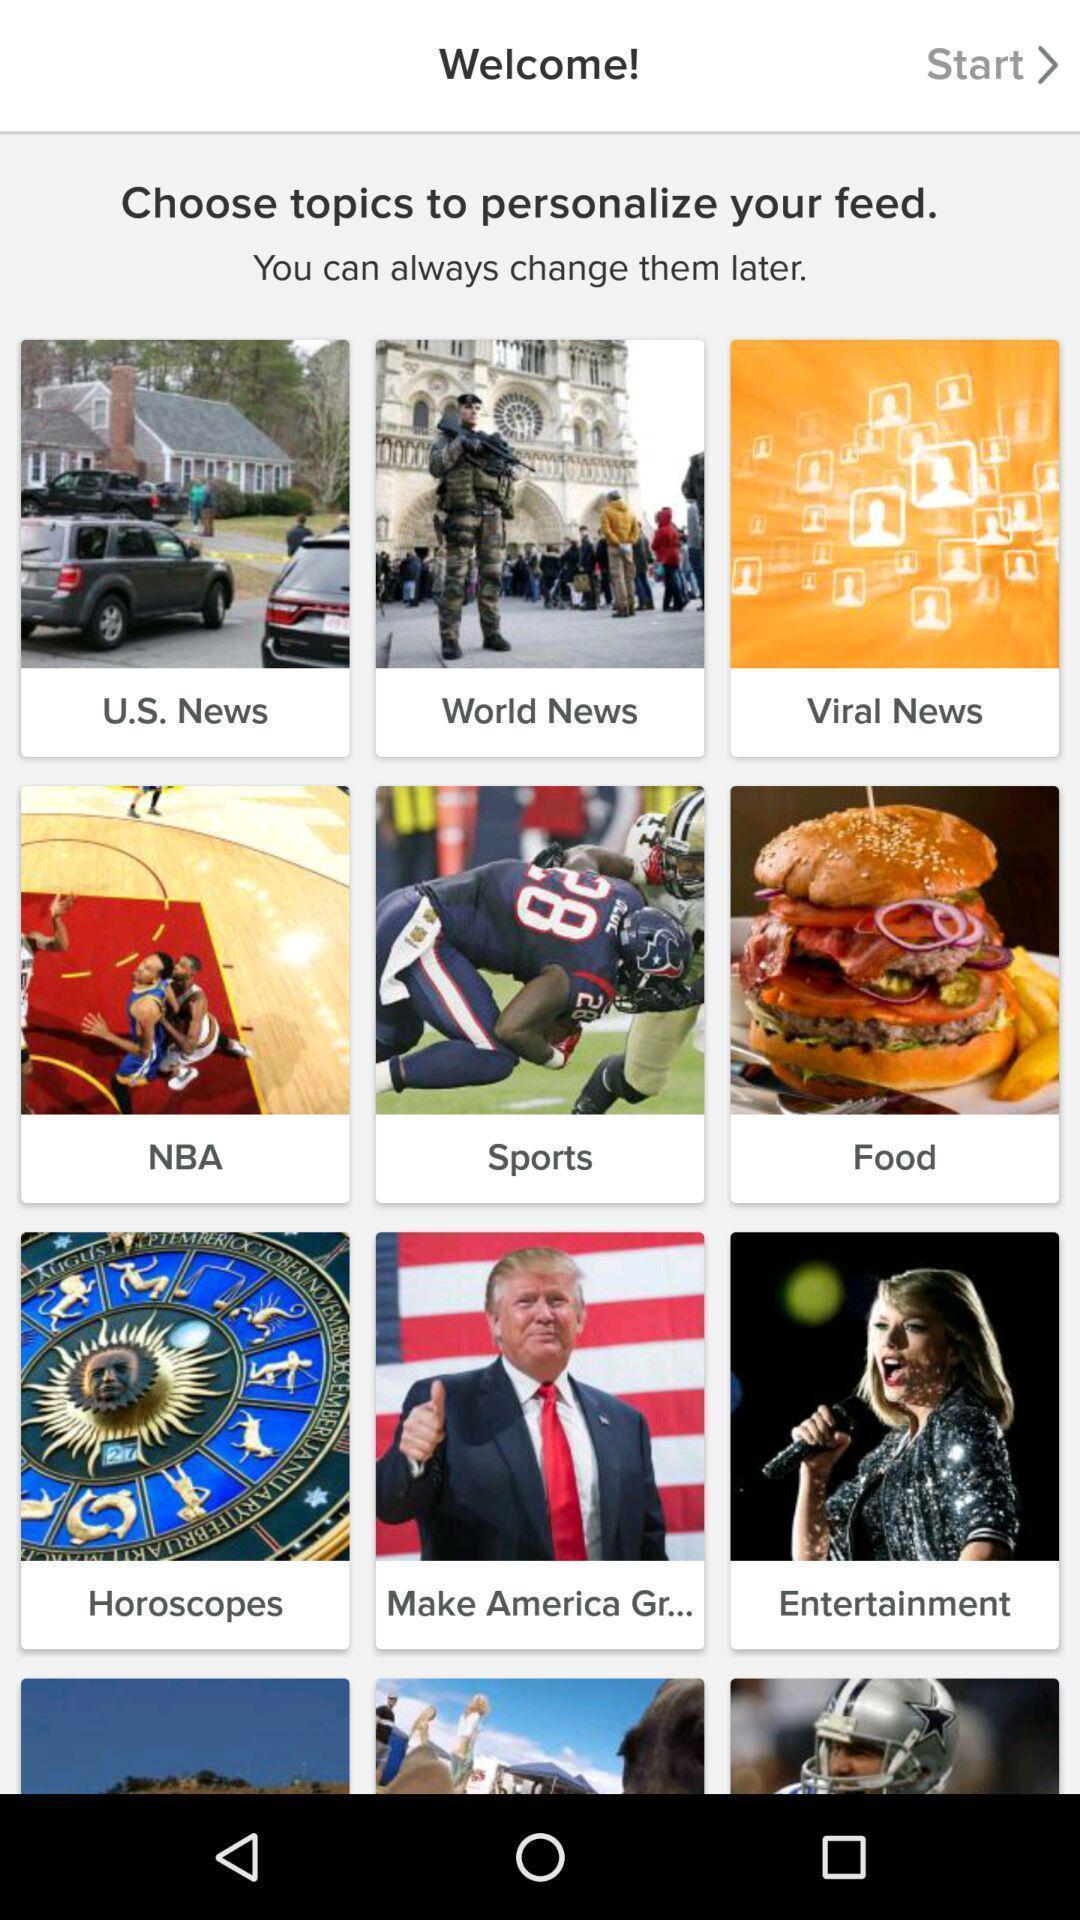What details can you identify in this image? Welcome page of a news content. 